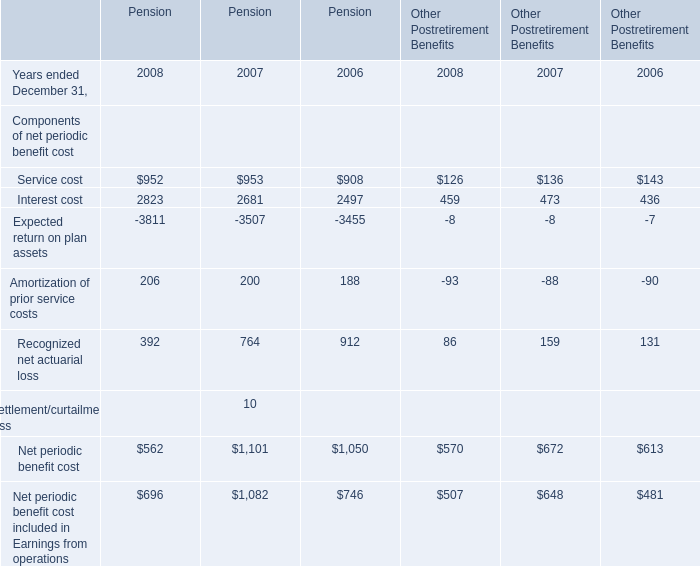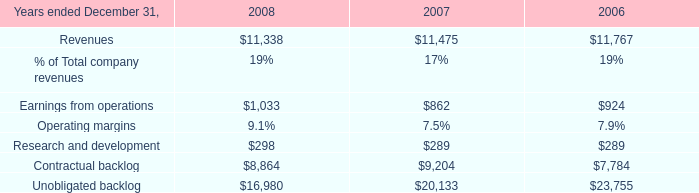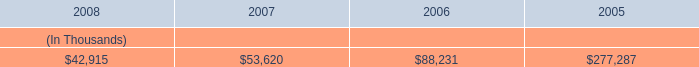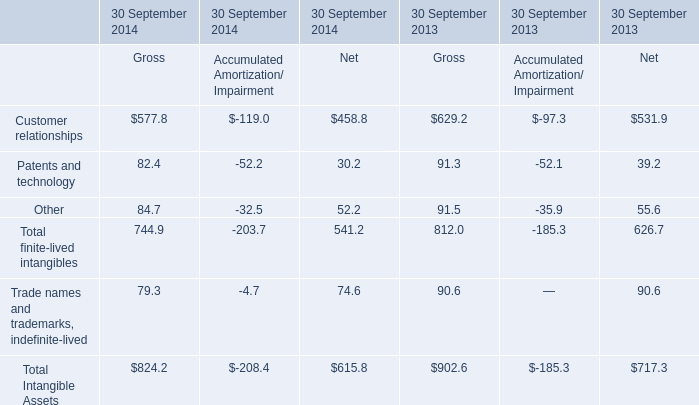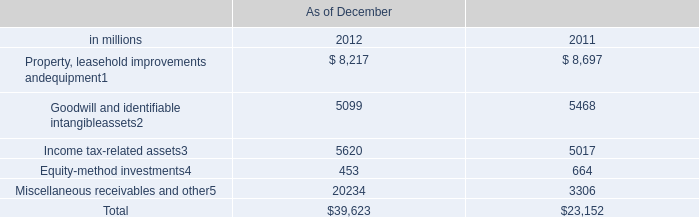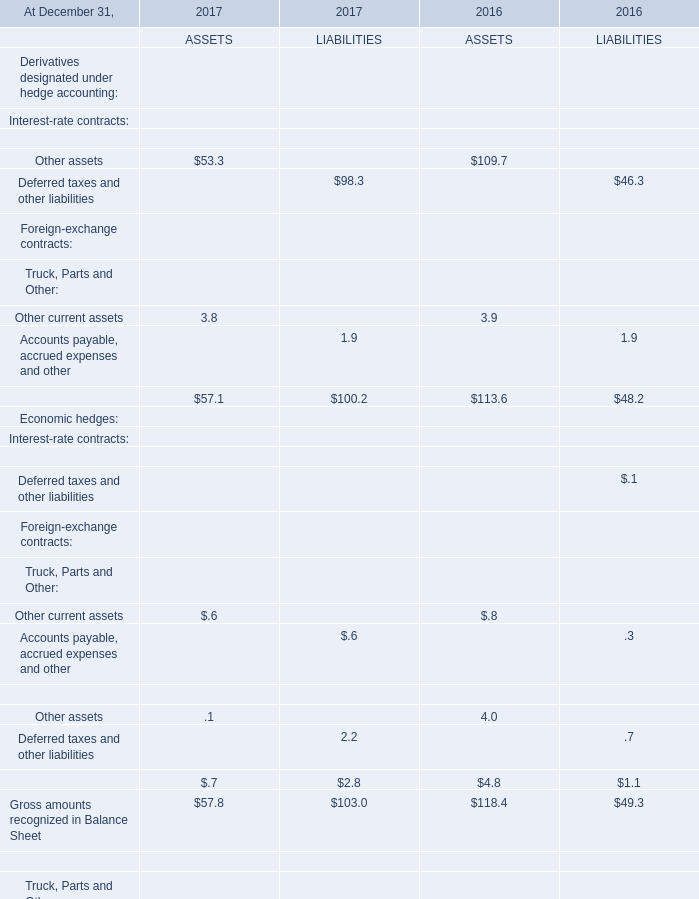what's the total amount of Earnings from operations of 2008, and Miscellaneous receivables and other of As of December 2011 ? 
Computations: (1033.0 + 3306.0)
Answer: 4339.0. 